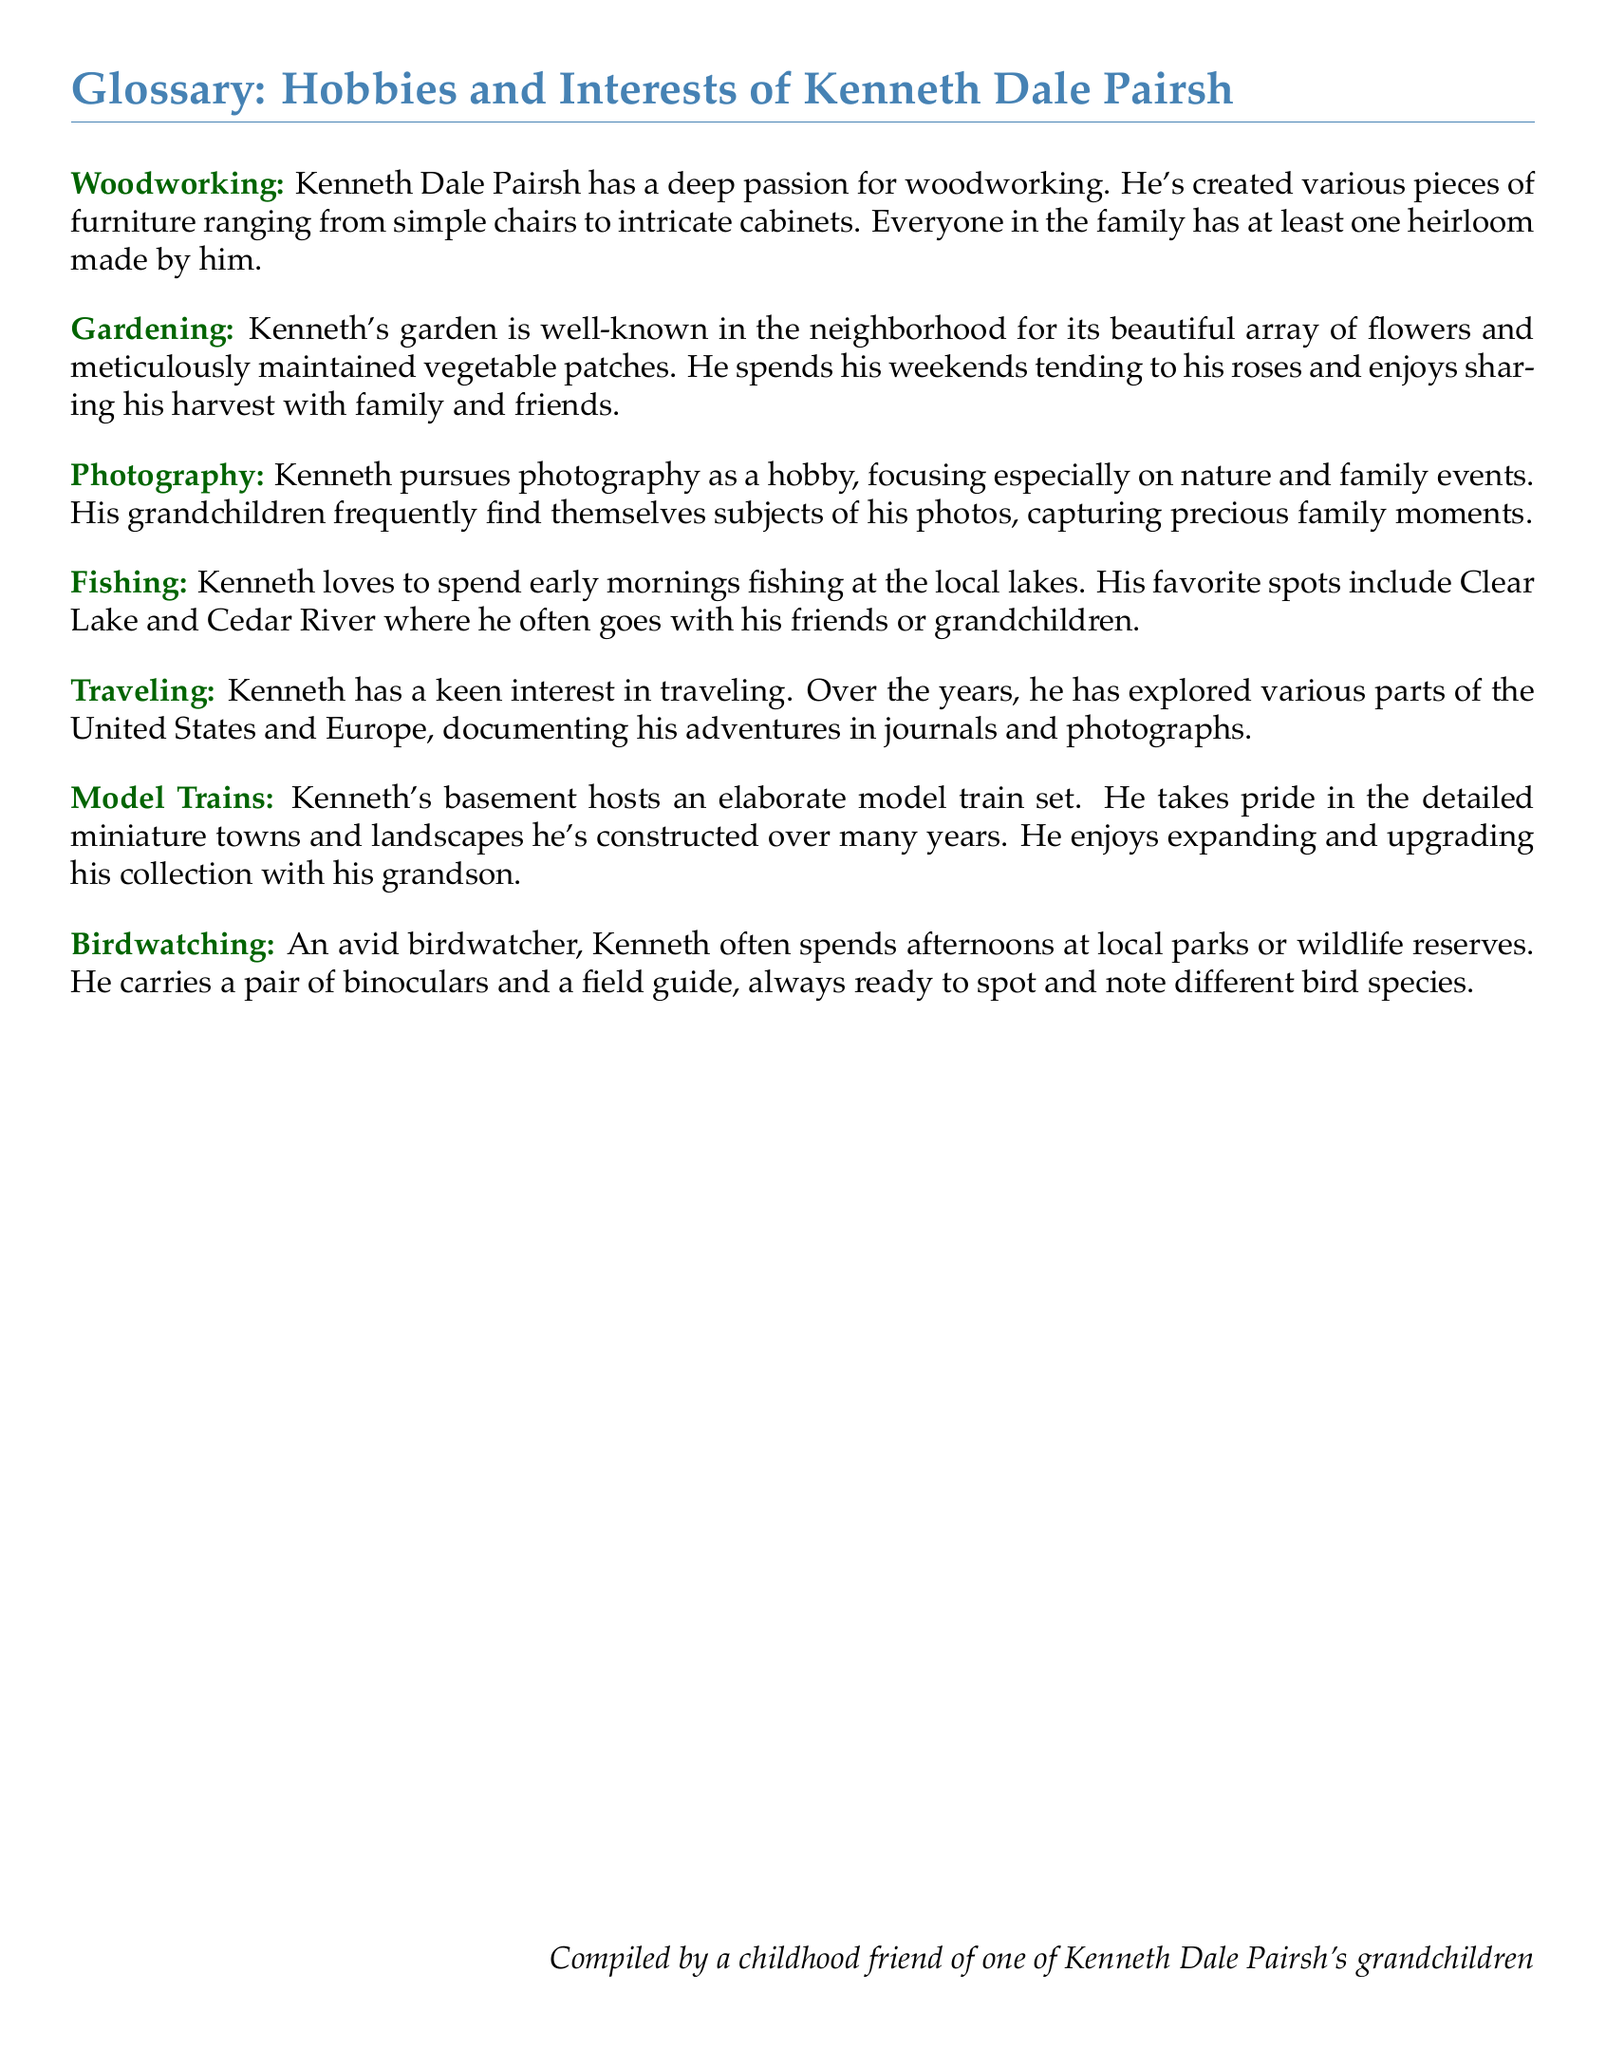What is Kenneth's main hobby related to furniture? The document states that Kenneth has a deep passion for woodworking and has created various pieces of furniture.
Answer: Woodworking What type of garden does Kenneth maintain? The document describes Kenneth's garden as having a beautiful array of flowers and meticulously maintained vegetable patches.
Answer: Flowers and vegetables What activity does Kenneth enjoy on early mornings? According to the document, Kenneth loves to spend early mornings fishing.
Answer: Fishing Which type of photography is Kenneth particularly interested in? The document notes that Kenneth focuses especially on nature and family events in his photography hobby.
Answer: Nature and family events How does Kenneth document his travels? The document mentions that he documents his adventures in journals and photographs.
Answer: Journals and photographs With whom does Kenneth often expand his model train collection? The document states that he enjoys expanding and upgrading his model train collection with his grandson.
Answer: His grandson What tool does Kenneth use for birdwatching? According to the document, Kenneth carries a pair of binoculars for birdwatching.
Answer: Binoculars What is the document's main focus? The document is a glossary that highlights the hobbies and interests of Kenneth Dale Pairsh.
Answer: Hobbies and interests 